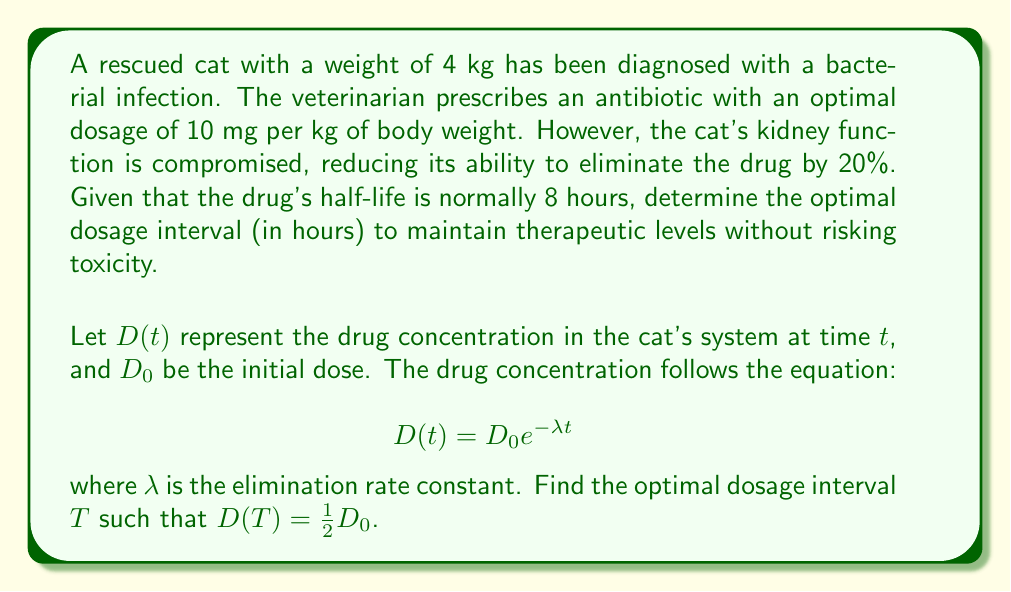What is the answer to this math problem? To solve this inverse problem, we need to follow these steps:

1) First, calculate the initial dose $D_0$:
   $D_0 = 10 \text{ mg/kg} \times 4 \text{ kg} = 40 \text{ mg}$

2) In a normal cat, the half-life is 8 hours. We can use this to find the normal elimination rate constant $\lambda_n$:
   $$\frac{1}{2} = e^{-\lambda_n \cdot 8}$$
   $$\ln(\frac{1}{2}) = -8\lambda_n$$
   $$\lambda_n = \frac{\ln(2)}{8} \approx 0.0866 \text{ hr}^{-1}$$

3) However, this cat's kidney function is compromised, reducing elimination by 20%. So the actual $\lambda$ is:
   $$\lambda = \lambda_n \cdot (1 - 0.2) = 0.0866 \cdot 0.8 \approx 0.0693 \text{ hr}^{-1}$$

4) Now, we want to find $T$ such that $D(T) = \frac{1}{2}D_0$. Using the given equation:
   $$\frac{1}{2}D_0 = D_0 e^{-\lambda T}$$

5) Simplify and solve for $T$:
   $$\frac{1}{2} = e^{-\lambda T}$$
   $$\ln(\frac{1}{2}) = -\lambda T$$
   $$T = \frac{\ln(2)}{\lambda} \approx \frac{0.693}{0.0693} \approx 10 \text{ hours}$$

Therefore, the optimal dosage interval is approximately 10 hours.
Answer: 10 hours 